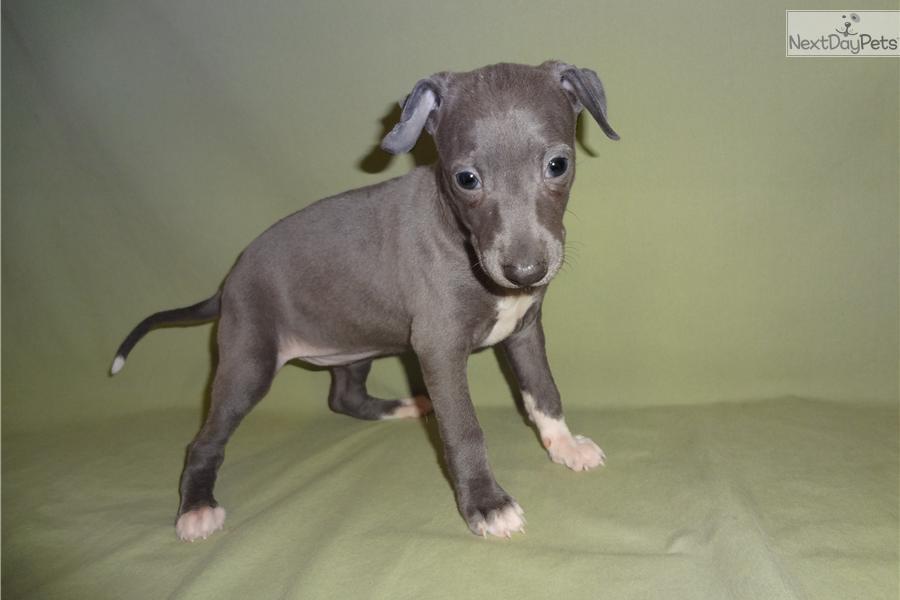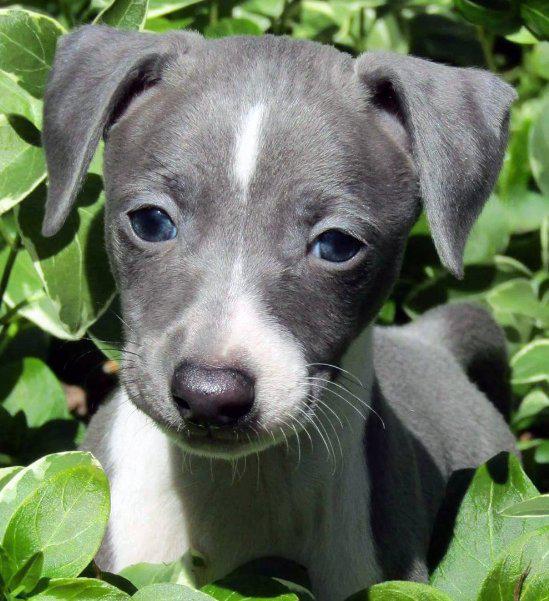The first image is the image on the left, the second image is the image on the right. Given the left and right images, does the statement "All images show one dog, with the dog on the right standing indoors." hold true? Answer yes or no. No. The first image is the image on the left, the second image is the image on the right. Given the left and right images, does the statement "the dog in the image on the right is standing on all fours" hold true? Answer yes or no. No. 